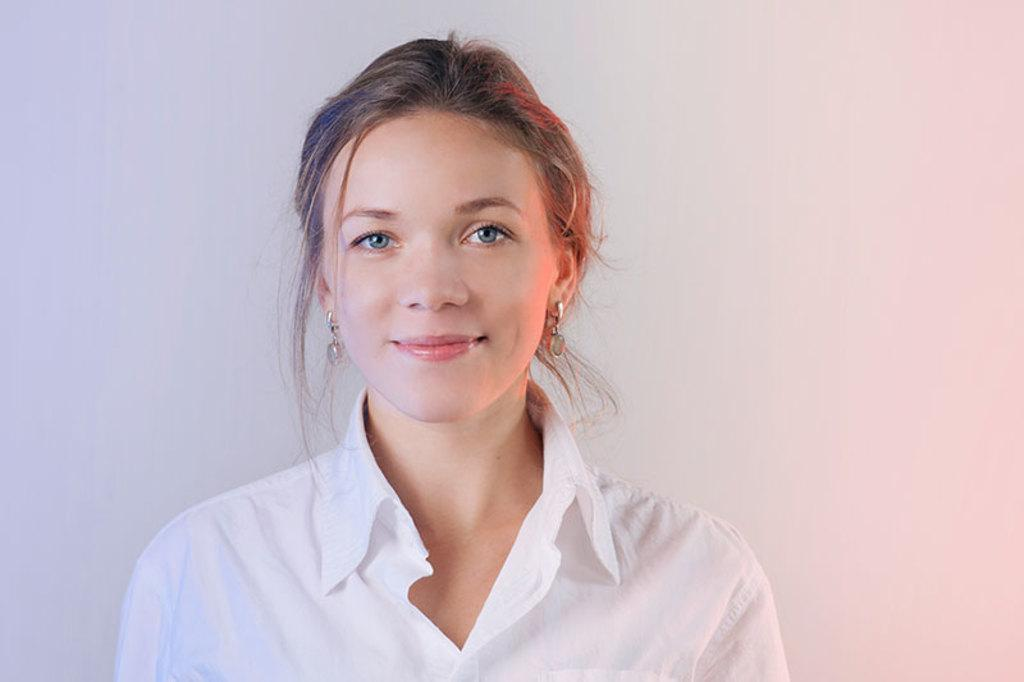What is the main subject of the image? The main subject of the image is a woman. What is the woman wearing in the image? The woman is wearing a white dress in the image. Are there any accessories visible on the woman? Yes, the woman is wearing earrings in the image. What is the woman's facial expression in the image? The woman is smiling in the image. What letter is the woman holding in the image? There is no letter present in the image; the woman is not holding anything. Is the woman standing near a stove in the image? There is no stove present in the image; it only features the woman. 